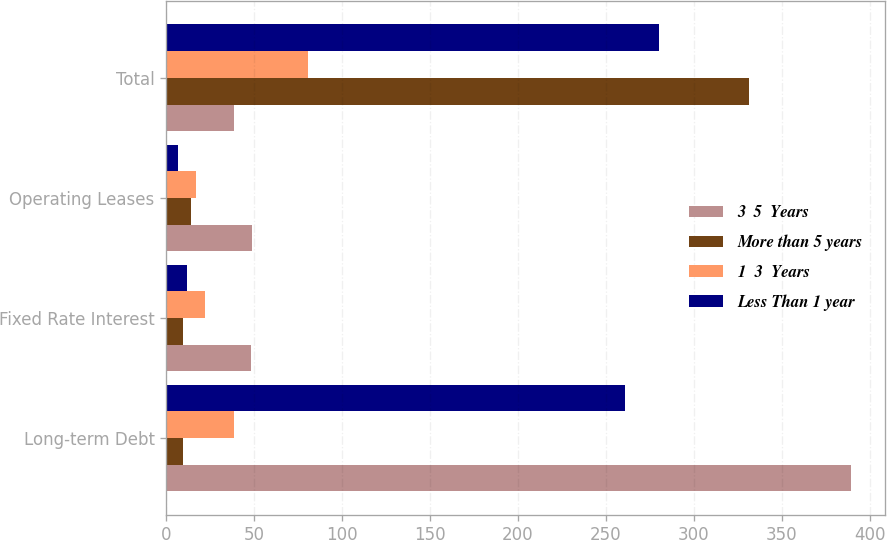Convert chart. <chart><loc_0><loc_0><loc_500><loc_500><stacked_bar_chart><ecel><fcel>Long-term Debt<fcel>Fixed Rate Interest<fcel>Operating Leases<fcel>Total<nl><fcel>3  5  Years<fcel>389.2<fcel>48.1<fcel>49<fcel>38.6<nl><fcel>More than 5 years<fcel>9.6<fcel>9.7<fcel>14.1<fcel>331.5<nl><fcel>1  3  Years<fcel>38.6<fcel>22.1<fcel>16.8<fcel>80.7<nl><fcel>Less Than 1 year<fcel>261.1<fcel>12<fcel>6.9<fcel>280<nl></chart> 